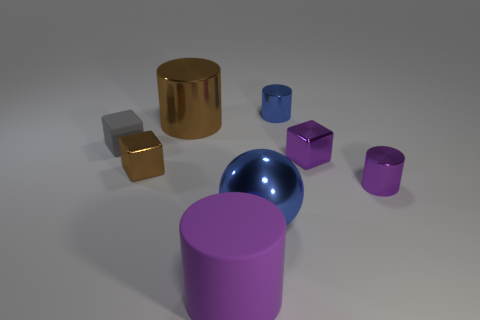What can you tell me about the lighting in the scene? The lighting in the scene is soft and diffused, coming from the upper left direction. It casts gentle shadows on the right sides of the objects, providing a sense of depth and dimension to the overall image. 